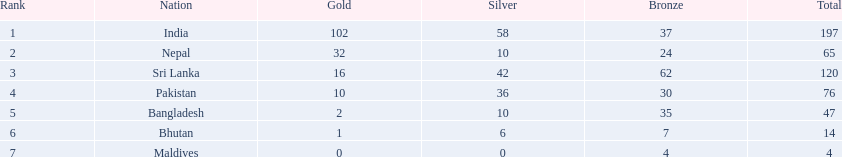What was the overall count of gold medals for the teams? 102, 32, 16, 10, 2, 1, 0. Which nation was unable to obtain a gold medal? Maldives. 